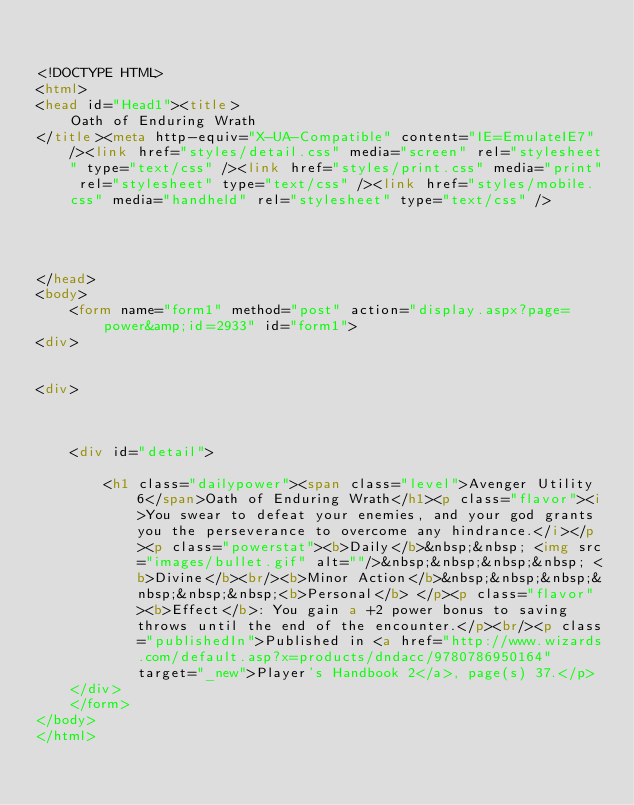Convert code to text. <code><loc_0><loc_0><loc_500><loc_500><_HTML_>

<!DOCTYPE HTML>
<html>
<head id="Head1"><title>
	Oath of Enduring Wrath
</title><meta http-equiv="X-UA-Compatible" content="IE=EmulateIE7" /><link href="styles/detail.css" media="screen" rel="stylesheet" type="text/css" /><link href="styles/print.css" media="print" rel="stylesheet" type="text/css" /><link href="styles/mobile.css" media="handheld" rel="stylesheet" type="text/css" />
    
    
    

</head>
<body>
    <form name="form1" method="post" action="display.aspx?page=power&amp;id=2933" id="form1">
<div>


<div>

	
	
    <div id="detail">
		
		<h1 class="dailypower"><span class="level">Avenger Utility 6</span>Oath of Enduring Wrath</h1><p class="flavor"><i>You swear to defeat your enemies, and your god grants you the perseverance to overcome any hindrance.</i></p><p class="powerstat"><b>Daily</b>&nbsp;&nbsp; <img src="images/bullet.gif" alt=""/>&nbsp;&nbsp;&nbsp;&nbsp; <b>Divine</b><br/><b>Minor Action</b>&nbsp;&nbsp;&nbsp;&nbsp;&nbsp;&nbsp;<b>Personal</b> </p><p class="flavor"><b>Effect</b>: You gain a +2 power bonus to saving throws until the end of the encounter.</p><br/><p class="publishedIn">Published in <a href="http://www.wizards.com/default.asp?x=products/dndacc/9780786950164" target="_new">Player's Handbook 2</a>, page(s) 37.</p>
    </div>
    </form>
</body>
</html>


</code> 